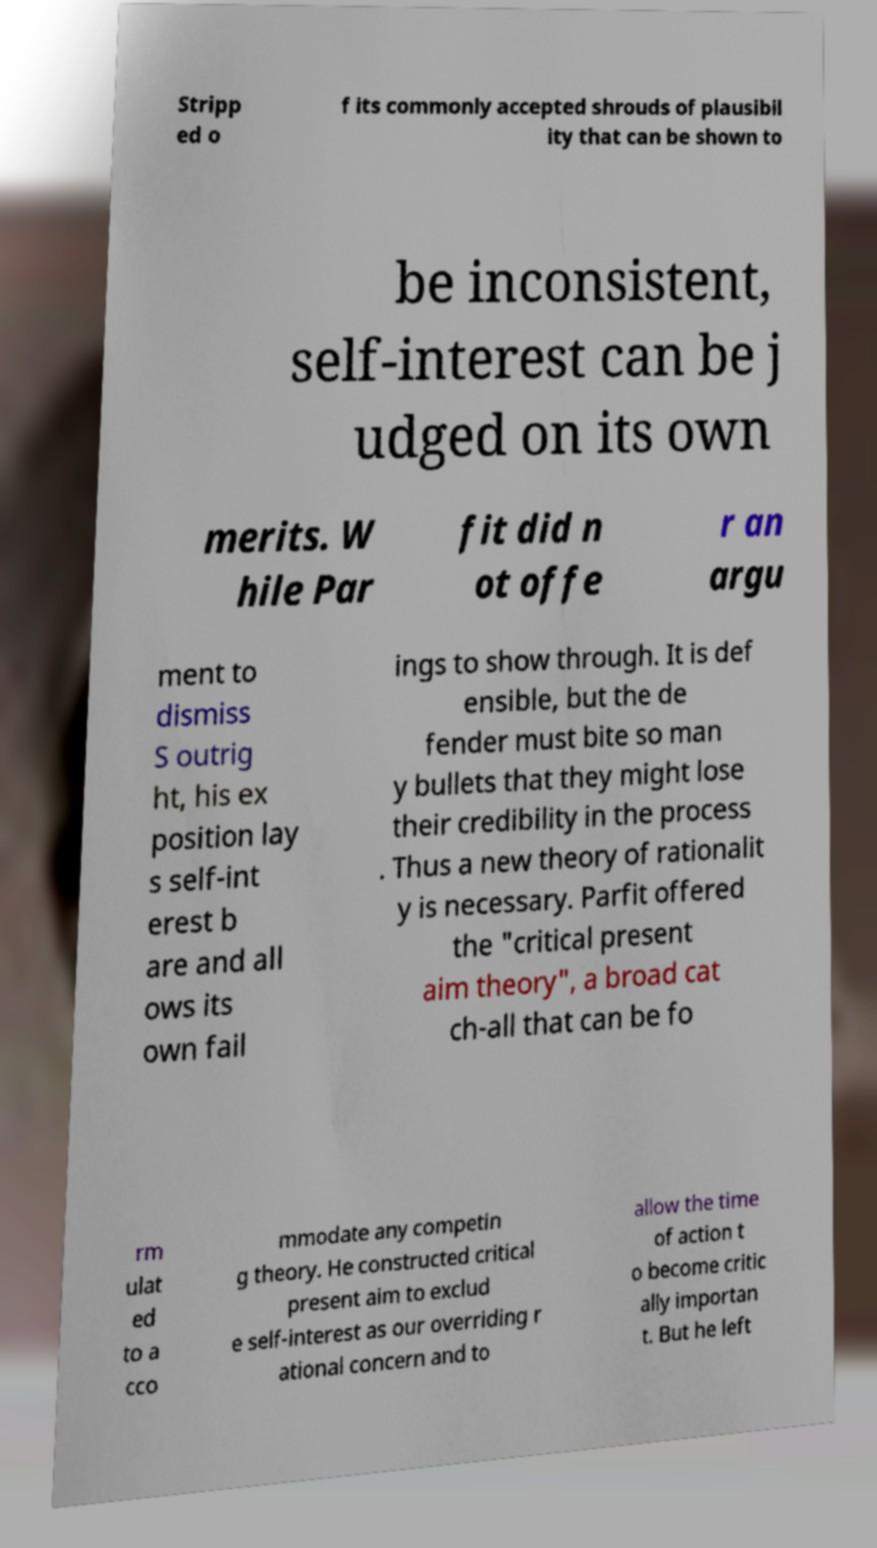Please read and relay the text visible in this image. What does it say? Stripp ed o f its commonly accepted shrouds of plausibil ity that can be shown to be inconsistent, self-interest can be j udged on its own merits. W hile Par fit did n ot offe r an argu ment to dismiss S outrig ht, his ex position lay s self-int erest b are and all ows its own fail ings to show through. It is def ensible, but the de fender must bite so man y bullets that they might lose their credibility in the process . Thus a new theory of rationalit y is necessary. Parfit offered the "critical present aim theory", a broad cat ch-all that can be fo rm ulat ed to a cco mmodate any competin g theory. He constructed critical present aim to exclud e self-interest as our overriding r ational concern and to allow the time of action t o become critic ally importan t. But he left 